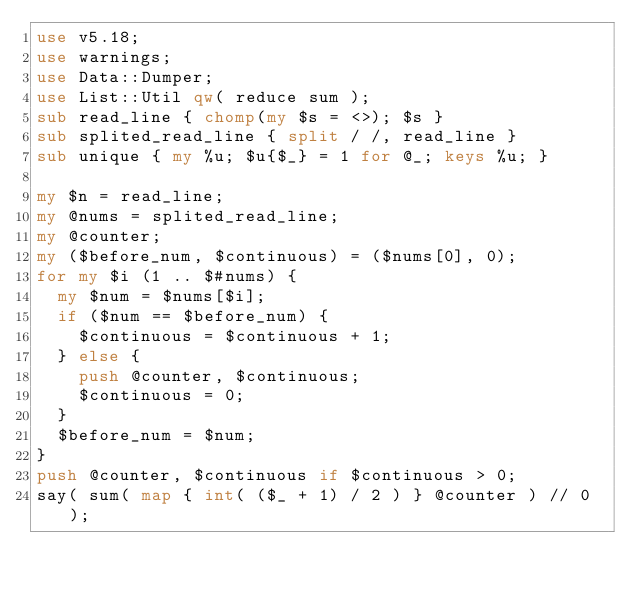<code> <loc_0><loc_0><loc_500><loc_500><_Perl_>use v5.18;
use warnings;
use Data::Dumper;
use List::Util qw( reduce sum );
sub read_line { chomp(my $s = <>); $s }
sub splited_read_line { split / /, read_line }
sub unique { my %u; $u{$_} = 1 for @_; keys %u; }

my $n = read_line;
my @nums = splited_read_line;
my @counter;
my ($before_num, $continuous) = ($nums[0], 0);
for my $i (1 .. $#nums) {
  my $num = $nums[$i];
  if ($num == $before_num) {
    $continuous = $continuous + 1;
  } else {
    push @counter, $continuous;
    $continuous = 0;
  }
  $before_num = $num;
}
push @counter, $continuous if $continuous > 0;
say( sum( map { int( ($_ + 1) / 2 ) } @counter ) // 0 );
</code> 